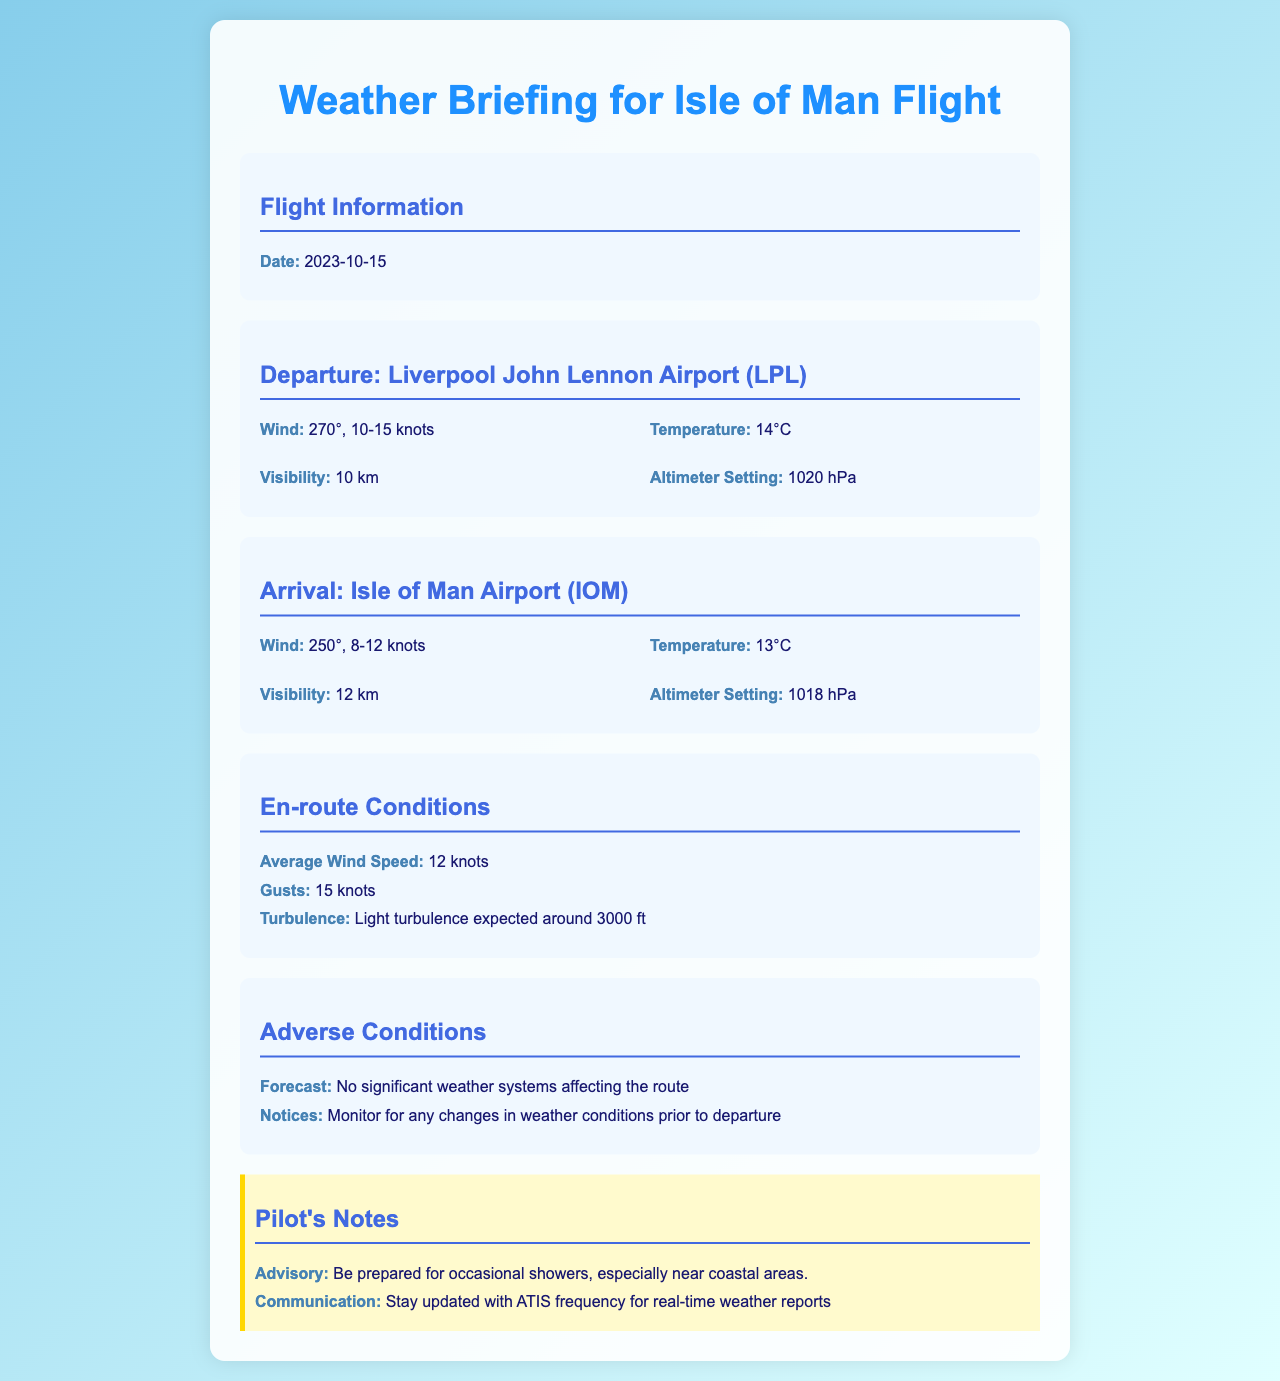What is the date of the weather briefing? The date is stated in the flight information section of the document.
Answer: 2023-10-15 What is the expected wind speed at Liverpool John Lennon Airport? The wind speed for the departure airport is provided in the details for Liverpool John Lennon Airport.
Answer: 10-15 knots What is the visibility at Isle of Man Airport? The visibility for the arrival airport is specified in the arrival section of the document.
Answer: 12 km What is the temperature when departing from Liverpool? The temperature is listed in the conditions for Liverpool John Lennon Airport.
Answer: 14°C What is the average wind speed en-route? This information is included in the en-route conditions section of the document.
Answer: 12 knots What type of turbulence is expected? The document indicates the expected turbulence conditions for the flight.
Answer: Light turbulence What should pilots monitor before departure? The document suggests precautions in the adverse conditions section.
Answer: Weather conditions What is the altimeter setting upon arrival at Isle of Man? This detail is included in the arrival section of the document.
Answer: 1018 hPa What advisory is given regarding showers? The pilot's notes section gives specific advisories about the weather.
Answer: Occasional showers 